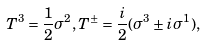Convert formula to latex. <formula><loc_0><loc_0><loc_500><loc_500>T ^ { 3 } = \frac { 1 } { 2 } \sigma ^ { 2 } , T ^ { \pm } = \frac { i } { 2 } ( \sigma ^ { 3 } \pm i \sigma ^ { 1 } ) ,</formula> 